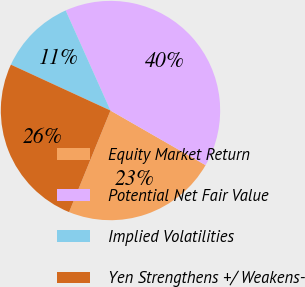Convert chart. <chart><loc_0><loc_0><loc_500><loc_500><pie_chart><fcel>Equity Market Return<fcel>Potential Net Fair Value<fcel>Implied Volatilities<fcel>Yen Strengthens +/ Weakens-<nl><fcel>22.86%<fcel>40.0%<fcel>11.43%<fcel>25.71%<nl></chart> 